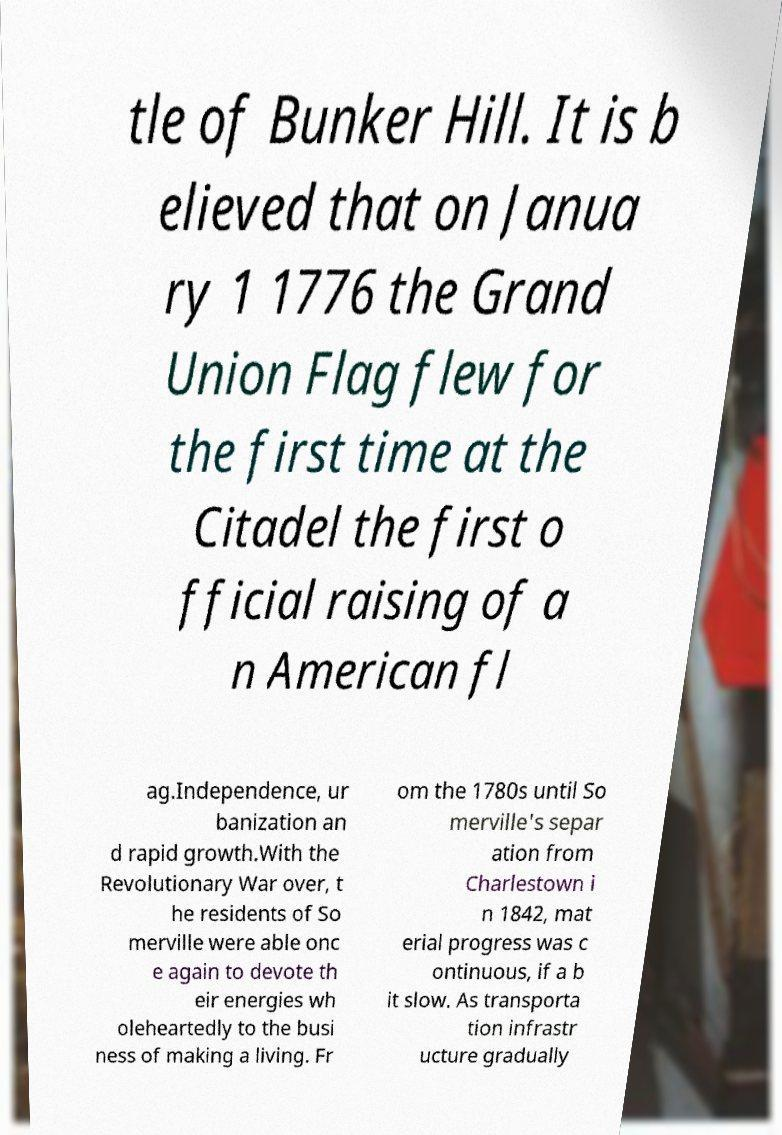What messages or text are displayed in this image? I need them in a readable, typed format. tle of Bunker Hill. It is b elieved that on Janua ry 1 1776 the Grand Union Flag flew for the first time at the Citadel the first o fficial raising of a n American fl ag.Independence, ur banization an d rapid growth.With the Revolutionary War over, t he residents of So merville were able onc e again to devote th eir energies wh oleheartedly to the busi ness of making a living. Fr om the 1780s until So merville's separ ation from Charlestown i n 1842, mat erial progress was c ontinuous, if a b it slow. As transporta tion infrastr ucture gradually 